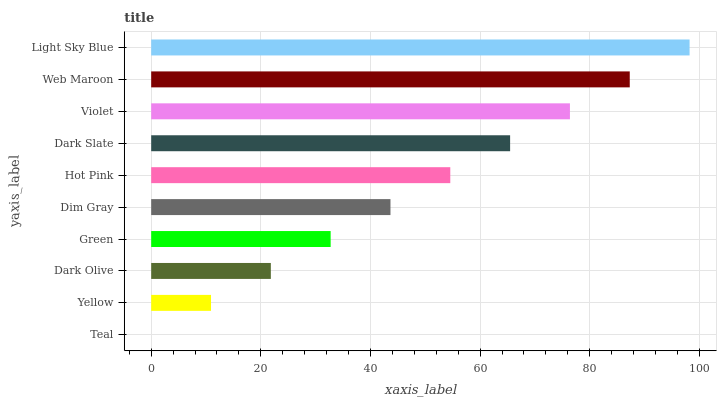Is Teal the minimum?
Answer yes or no. Yes. Is Light Sky Blue the maximum?
Answer yes or no. Yes. Is Yellow the minimum?
Answer yes or no. No. Is Yellow the maximum?
Answer yes or no. No. Is Yellow greater than Teal?
Answer yes or no. Yes. Is Teal less than Yellow?
Answer yes or no. Yes. Is Teal greater than Yellow?
Answer yes or no. No. Is Yellow less than Teal?
Answer yes or no. No. Is Hot Pink the high median?
Answer yes or no. Yes. Is Dim Gray the low median?
Answer yes or no. Yes. Is Light Sky Blue the high median?
Answer yes or no. No. Is Web Maroon the low median?
Answer yes or no. No. 